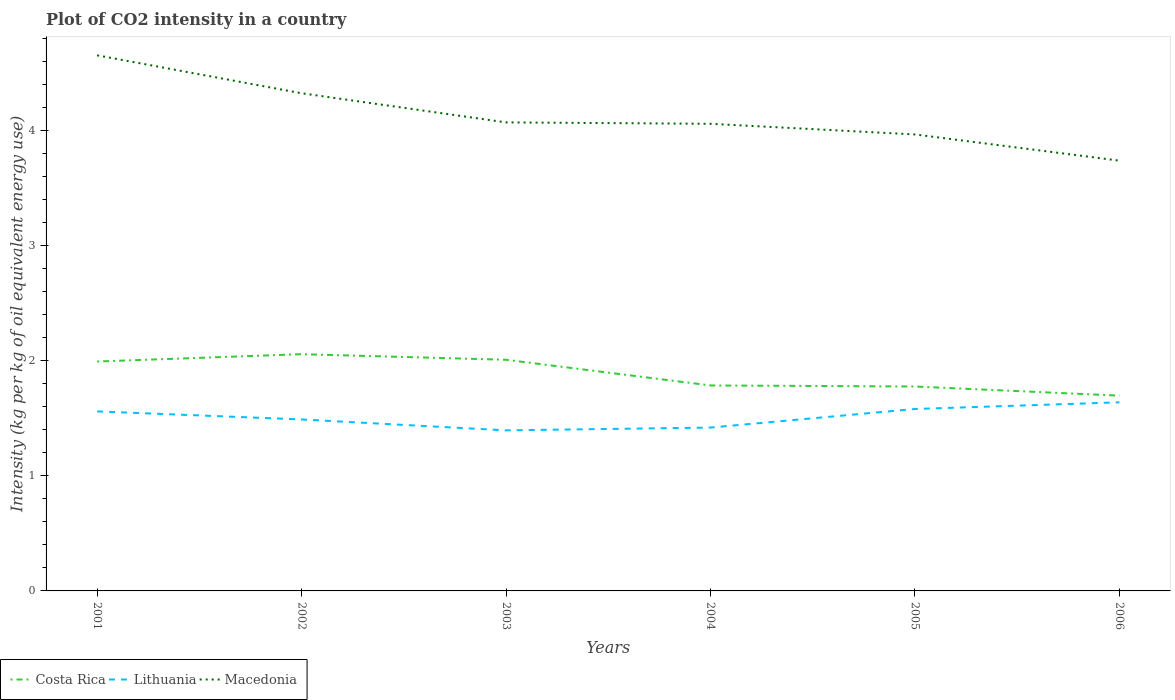Does the line corresponding to Macedonia intersect with the line corresponding to Costa Rica?
Your response must be concise. No. Across all years, what is the maximum CO2 intensity in in Costa Rica?
Provide a succinct answer. 1.7. What is the total CO2 intensity in in Lithuania in the graph?
Keep it short and to the point. -0.09. What is the difference between the highest and the second highest CO2 intensity in in Lithuania?
Give a very brief answer. 0.24. What is the difference between the highest and the lowest CO2 intensity in in Costa Rica?
Ensure brevity in your answer.  3. How many lines are there?
Keep it short and to the point. 3. How many years are there in the graph?
Make the answer very short. 6. What is the difference between two consecutive major ticks on the Y-axis?
Keep it short and to the point. 1. Does the graph contain any zero values?
Your answer should be compact. No. How many legend labels are there?
Ensure brevity in your answer.  3. What is the title of the graph?
Keep it short and to the point. Plot of CO2 intensity in a country. What is the label or title of the Y-axis?
Offer a very short reply. Intensity (kg per kg of oil equivalent energy use). What is the Intensity (kg per kg of oil equivalent energy use) of Costa Rica in 2001?
Keep it short and to the point. 1.99. What is the Intensity (kg per kg of oil equivalent energy use) of Lithuania in 2001?
Ensure brevity in your answer.  1.56. What is the Intensity (kg per kg of oil equivalent energy use) in Macedonia in 2001?
Offer a terse response. 4.66. What is the Intensity (kg per kg of oil equivalent energy use) of Costa Rica in 2002?
Make the answer very short. 2.06. What is the Intensity (kg per kg of oil equivalent energy use) in Lithuania in 2002?
Give a very brief answer. 1.49. What is the Intensity (kg per kg of oil equivalent energy use) of Macedonia in 2002?
Give a very brief answer. 4.33. What is the Intensity (kg per kg of oil equivalent energy use) of Costa Rica in 2003?
Ensure brevity in your answer.  2.01. What is the Intensity (kg per kg of oil equivalent energy use) in Lithuania in 2003?
Offer a terse response. 1.4. What is the Intensity (kg per kg of oil equivalent energy use) in Macedonia in 2003?
Keep it short and to the point. 4.07. What is the Intensity (kg per kg of oil equivalent energy use) in Costa Rica in 2004?
Ensure brevity in your answer.  1.79. What is the Intensity (kg per kg of oil equivalent energy use) in Lithuania in 2004?
Ensure brevity in your answer.  1.42. What is the Intensity (kg per kg of oil equivalent energy use) of Macedonia in 2004?
Your answer should be very brief. 4.06. What is the Intensity (kg per kg of oil equivalent energy use) of Costa Rica in 2005?
Your response must be concise. 1.78. What is the Intensity (kg per kg of oil equivalent energy use) of Lithuania in 2005?
Your answer should be compact. 1.58. What is the Intensity (kg per kg of oil equivalent energy use) of Macedonia in 2005?
Provide a succinct answer. 3.97. What is the Intensity (kg per kg of oil equivalent energy use) of Costa Rica in 2006?
Ensure brevity in your answer.  1.7. What is the Intensity (kg per kg of oil equivalent energy use) of Lithuania in 2006?
Give a very brief answer. 1.64. What is the Intensity (kg per kg of oil equivalent energy use) in Macedonia in 2006?
Your answer should be very brief. 3.74. Across all years, what is the maximum Intensity (kg per kg of oil equivalent energy use) of Costa Rica?
Provide a short and direct response. 2.06. Across all years, what is the maximum Intensity (kg per kg of oil equivalent energy use) of Lithuania?
Make the answer very short. 1.64. Across all years, what is the maximum Intensity (kg per kg of oil equivalent energy use) of Macedonia?
Your response must be concise. 4.66. Across all years, what is the minimum Intensity (kg per kg of oil equivalent energy use) of Costa Rica?
Offer a very short reply. 1.7. Across all years, what is the minimum Intensity (kg per kg of oil equivalent energy use) in Lithuania?
Give a very brief answer. 1.4. Across all years, what is the minimum Intensity (kg per kg of oil equivalent energy use) of Macedonia?
Provide a succinct answer. 3.74. What is the total Intensity (kg per kg of oil equivalent energy use) in Costa Rica in the graph?
Provide a succinct answer. 11.32. What is the total Intensity (kg per kg of oil equivalent energy use) of Lithuania in the graph?
Make the answer very short. 9.09. What is the total Intensity (kg per kg of oil equivalent energy use) of Macedonia in the graph?
Your answer should be compact. 24.83. What is the difference between the Intensity (kg per kg of oil equivalent energy use) in Costa Rica in 2001 and that in 2002?
Your answer should be very brief. -0.06. What is the difference between the Intensity (kg per kg of oil equivalent energy use) of Lithuania in 2001 and that in 2002?
Make the answer very short. 0.07. What is the difference between the Intensity (kg per kg of oil equivalent energy use) of Macedonia in 2001 and that in 2002?
Give a very brief answer. 0.33. What is the difference between the Intensity (kg per kg of oil equivalent energy use) in Costa Rica in 2001 and that in 2003?
Offer a terse response. -0.02. What is the difference between the Intensity (kg per kg of oil equivalent energy use) of Lithuania in 2001 and that in 2003?
Your response must be concise. 0.17. What is the difference between the Intensity (kg per kg of oil equivalent energy use) in Macedonia in 2001 and that in 2003?
Make the answer very short. 0.58. What is the difference between the Intensity (kg per kg of oil equivalent energy use) of Costa Rica in 2001 and that in 2004?
Provide a short and direct response. 0.21. What is the difference between the Intensity (kg per kg of oil equivalent energy use) of Lithuania in 2001 and that in 2004?
Offer a very short reply. 0.14. What is the difference between the Intensity (kg per kg of oil equivalent energy use) of Macedonia in 2001 and that in 2004?
Offer a terse response. 0.6. What is the difference between the Intensity (kg per kg of oil equivalent energy use) of Costa Rica in 2001 and that in 2005?
Keep it short and to the point. 0.22. What is the difference between the Intensity (kg per kg of oil equivalent energy use) in Lithuania in 2001 and that in 2005?
Offer a very short reply. -0.02. What is the difference between the Intensity (kg per kg of oil equivalent energy use) of Macedonia in 2001 and that in 2005?
Keep it short and to the point. 0.69. What is the difference between the Intensity (kg per kg of oil equivalent energy use) of Costa Rica in 2001 and that in 2006?
Provide a short and direct response. 0.3. What is the difference between the Intensity (kg per kg of oil equivalent energy use) in Lithuania in 2001 and that in 2006?
Provide a succinct answer. -0.08. What is the difference between the Intensity (kg per kg of oil equivalent energy use) of Macedonia in 2001 and that in 2006?
Your response must be concise. 0.92. What is the difference between the Intensity (kg per kg of oil equivalent energy use) in Costa Rica in 2002 and that in 2003?
Give a very brief answer. 0.05. What is the difference between the Intensity (kg per kg of oil equivalent energy use) of Lithuania in 2002 and that in 2003?
Give a very brief answer. 0.09. What is the difference between the Intensity (kg per kg of oil equivalent energy use) in Macedonia in 2002 and that in 2003?
Your response must be concise. 0.25. What is the difference between the Intensity (kg per kg of oil equivalent energy use) in Costa Rica in 2002 and that in 2004?
Make the answer very short. 0.27. What is the difference between the Intensity (kg per kg of oil equivalent energy use) in Lithuania in 2002 and that in 2004?
Make the answer very short. 0.07. What is the difference between the Intensity (kg per kg of oil equivalent energy use) of Macedonia in 2002 and that in 2004?
Your response must be concise. 0.27. What is the difference between the Intensity (kg per kg of oil equivalent energy use) in Costa Rica in 2002 and that in 2005?
Give a very brief answer. 0.28. What is the difference between the Intensity (kg per kg of oil equivalent energy use) of Lithuania in 2002 and that in 2005?
Provide a succinct answer. -0.09. What is the difference between the Intensity (kg per kg of oil equivalent energy use) of Macedonia in 2002 and that in 2005?
Provide a short and direct response. 0.36. What is the difference between the Intensity (kg per kg of oil equivalent energy use) of Costa Rica in 2002 and that in 2006?
Your response must be concise. 0.36. What is the difference between the Intensity (kg per kg of oil equivalent energy use) of Lithuania in 2002 and that in 2006?
Offer a terse response. -0.15. What is the difference between the Intensity (kg per kg of oil equivalent energy use) of Macedonia in 2002 and that in 2006?
Offer a terse response. 0.59. What is the difference between the Intensity (kg per kg of oil equivalent energy use) in Costa Rica in 2003 and that in 2004?
Keep it short and to the point. 0.22. What is the difference between the Intensity (kg per kg of oil equivalent energy use) in Lithuania in 2003 and that in 2004?
Provide a succinct answer. -0.02. What is the difference between the Intensity (kg per kg of oil equivalent energy use) of Macedonia in 2003 and that in 2004?
Provide a short and direct response. 0.01. What is the difference between the Intensity (kg per kg of oil equivalent energy use) of Costa Rica in 2003 and that in 2005?
Your answer should be very brief. 0.23. What is the difference between the Intensity (kg per kg of oil equivalent energy use) in Lithuania in 2003 and that in 2005?
Offer a very short reply. -0.19. What is the difference between the Intensity (kg per kg of oil equivalent energy use) in Macedonia in 2003 and that in 2005?
Provide a succinct answer. 0.1. What is the difference between the Intensity (kg per kg of oil equivalent energy use) in Costa Rica in 2003 and that in 2006?
Your answer should be very brief. 0.31. What is the difference between the Intensity (kg per kg of oil equivalent energy use) of Lithuania in 2003 and that in 2006?
Your response must be concise. -0.24. What is the difference between the Intensity (kg per kg of oil equivalent energy use) of Macedonia in 2003 and that in 2006?
Offer a terse response. 0.33. What is the difference between the Intensity (kg per kg of oil equivalent energy use) of Costa Rica in 2004 and that in 2005?
Make the answer very short. 0.01. What is the difference between the Intensity (kg per kg of oil equivalent energy use) in Lithuania in 2004 and that in 2005?
Give a very brief answer. -0.16. What is the difference between the Intensity (kg per kg of oil equivalent energy use) in Macedonia in 2004 and that in 2005?
Ensure brevity in your answer.  0.09. What is the difference between the Intensity (kg per kg of oil equivalent energy use) in Costa Rica in 2004 and that in 2006?
Ensure brevity in your answer.  0.09. What is the difference between the Intensity (kg per kg of oil equivalent energy use) in Lithuania in 2004 and that in 2006?
Offer a terse response. -0.22. What is the difference between the Intensity (kg per kg of oil equivalent energy use) in Macedonia in 2004 and that in 2006?
Keep it short and to the point. 0.32. What is the difference between the Intensity (kg per kg of oil equivalent energy use) in Costa Rica in 2005 and that in 2006?
Give a very brief answer. 0.08. What is the difference between the Intensity (kg per kg of oil equivalent energy use) in Lithuania in 2005 and that in 2006?
Offer a very short reply. -0.06. What is the difference between the Intensity (kg per kg of oil equivalent energy use) in Macedonia in 2005 and that in 2006?
Your response must be concise. 0.23. What is the difference between the Intensity (kg per kg of oil equivalent energy use) in Costa Rica in 2001 and the Intensity (kg per kg of oil equivalent energy use) in Lithuania in 2002?
Your response must be concise. 0.5. What is the difference between the Intensity (kg per kg of oil equivalent energy use) in Costa Rica in 2001 and the Intensity (kg per kg of oil equivalent energy use) in Macedonia in 2002?
Offer a terse response. -2.33. What is the difference between the Intensity (kg per kg of oil equivalent energy use) in Lithuania in 2001 and the Intensity (kg per kg of oil equivalent energy use) in Macedonia in 2002?
Give a very brief answer. -2.77. What is the difference between the Intensity (kg per kg of oil equivalent energy use) of Costa Rica in 2001 and the Intensity (kg per kg of oil equivalent energy use) of Lithuania in 2003?
Offer a very short reply. 0.6. What is the difference between the Intensity (kg per kg of oil equivalent energy use) in Costa Rica in 2001 and the Intensity (kg per kg of oil equivalent energy use) in Macedonia in 2003?
Provide a short and direct response. -2.08. What is the difference between the Intensity (kg per kg of oil equivalent energy use) of Lithuania in 2001 and the Intensity (kg per kg of oil equivalent energy use) of Macedonia in 2003?
Give a very brief answer. -2.51. What is the difference between the Intensity (kg per kg of oil equivalent energy use) of Costa Rica in 2001 and the Intensity (kg per kg of oil equivalent energy use) of Lithuania in 2004?
Your answer should be compact. 0.57. What is the difference between the Intensity (kg per kg of oil equivalent energy use) of Costa Rica in 2001 and the Intensity (kg per kg of oil equivalent energy use) of Macedonia in 2004?
Your answer should be compact. -2.07. What is the difference between the Intensity (kg per kg of oil equivalent energy use) of Lithuania in 2001 and the Intensity (kg per kg of oil equivalent energy use) of Macedonia in 2004?
Offer a very short reply. -2.5. What is the difference between the Intensity (kg per kg of oil equivalent energy use) of Costa Rica in 2001 and the Intensity (kg per kg of oil equivalent energy use) of Lithuania in 2005?
Give a very brief answer. 0.41. What is the difference between the Intensity (kg per kg of oil equivalent energy use) in Costa Rica in 2001 and the Intensity (kg per kg of oil equivalent energy use) in Macedonia in 2005?
Offer a very short reply. -1.97. What is the difference between the Intensity (kg per kg of oil equivalent energy use) of Lithuania in 2001 and the Intensity (kg per kg of oil equivalent energy use) of Macedonia in 2005?
Keep it short and to the point. -2.41. What is the difference between the Intensity (kg per kg of oil equivalent energy use) of Costa Rica in 2001 and the Intensity (kg per kg of oil equivalent energy use) of Lithuania in 2006?
Offer a very short reply. 0.35. What is the difference between the Intensity (kg per kg of oil equivalent energy use) of Costa Rica in 2001 and the Intensity (kg per kg of oil equivalent energy use) of Macedonia in 2006?
Keep it short and to the point. -1.75. What is the difference between the Intensity (kg per kg of oil equivalent energy use) in Lithuania in 2001 and the Intensity (kg per kg of oil equivalent energy use) in Macedonia in 2006?
Your answer should be very brief. -2.18. What is the difference between the Intensity (kg per kg of oil equivalent energy use) of Costa Rica in 2002 and the Intensity (kg per kg of oil equivalent energy use) of Lithuania in 2003?
Offer a terse response. 0.66. What is the difference between the Intensity (kg per kg of oil equivalent energy use) of Costa Rica in 2002 and the Intensity (kg per kg of oil equivalent energy use) of Macedonia in 2003?
Provide a succinct answer. -2.02. What is the difference between the Intensity (kg per kg of oil equivalent energy use) of Lithuania in 2002 and the Intensity (kg per kg of oil equivalent energy use) of Macedonia in 2003?
Ensure brevity in your answer.  -2.58. What is the difference between the Intensity (kg per kg of oil equivalent energy use) of Costa Rica in 2002 and the Intensity (kg per kg of oil equivalent energy use) of Lithuania in 2004?
Provide a short and direct response. 0.64. What is the difference between the Intensity (kg per kg of oil equivalent energy use) in Costa Rica in 2002 and the Intensity (kg per kg of oil equivalent energy use) in Macedonia in 2004?
Your answer should be compact. -2. What is the difference between the Intensity (kg per kg of oil equivalent energy use) of Lithuania in 2002 and the Intensity (kg per kg of oil equivalent energy use) of Macedonia in 2004?
Make the answer very short. -2.57. What is the difference between the Intensity (kg per kg of oil equivalent energy use) in Costa Rica in 2002 and the Intensity (kg per kg of oil equivalent energy use) in Lithuania in 2005?
Provide a succinct answer. 0.48. What is the difference between the Intensity (kg per kg of oil equivalent energy use) of Costa Rica in 2002 and the Intensity (kg per kg of oil equivalent energy use) of Macedonia in 2005?
Your response must be concise. -1.91. What is the difference between the Intensity (kg per kg of oil equivalent energy use) of Lithuania in 2002 and the Intensity (kg per kg of oil equivalent energy use) of Macedonia in 2005?
Give a very brief answer. -2.48. What is the difference between the Intensity (kg per kg of oil equivalent energy use) in Costa Rica in 2002 and the Intensity (kg per kg of oil equivalent energy use) in Lithuania in 2006?
Provide a short and direct response. 0.42. What is the difference between the Intensity (kg per kg of oil equivalent energy use) in Costa Rica in 2002 and the Intensity (kg per kg of oil equivalent energy use) in Macedonia in 2006?
Give a very brief answer. -1.68. What is the difference between the Intensity (kg per kg of oil equivalent energy use) in Lithuania in 2002 and the Intensity (kg per kg of oil equivalent energy use) in Macedonia in 2006?
Make the answer very short. -2.25. What is the difference between the Intensity (kg per kg of oil equivalent energy use) in Costa Rica in 2003 and the Intensity (kg per kg of oil equivalent energy use) in Lithuania in 2004?
Offer a very short reply. 0.59. What is the difference between the Intensity (kg per kg of oil equivalent energy use) in Costa Rica in 2003 and the Intensity (kg per kg of oil equivalent energy use) in Macedonia in 2004?
Your response must be concise. -2.05. What is the difference between the Intensity (kg per kg of oil equivalent energy use) in Lithuania in 2003 and the Intensity (kg per kg of oil equivalent energy use) in Macedonia in 2004?
Give a very brief answer. -2.67. What is the difference between the Intensity (kg per kg of oil equivalent energy use) in Costa Rica in 2003 and the Intensity (kg per kg of oil equivalent energy use) in Lithuania in 2005?
Offer a terse response. 0.43. What is the difference between the Intensity (kg per kg of oil equivalent energy use) of Costa Rica in 2003 and the Intensity (kg per kg of oil equivalent energy use) of Macedonia in 2005?
Your answer should be very brief. -1.96. What is the difference between the Intensity (kg per kg of oil equivalent energy use) in Lithuania in 2003 and the Intensity (kg per kg of oil equivalent energy use) in Macedonia in 2005?
Ensure brevity in your answer.  -2.57. What is the difference between the Intensity (kg per kg of oil equivalent energy use) of Costa Rica in 2003 and the Intensity (kg per kg of oil equivalent energy use) of Lithuania in 2006?
Offer a very short reply. 0.37. What is the difference between the Intensity (kg per kg of oil equivalent energy use) in Costa Rica in 2003 and the Intensity (kg per kg of oil equivalent energy use) in Macedonia in 2006?
Your answer should be very brief. -1.73. What is the difference between the Intensity (kg per kg of oil equivalent energy use) of Lithuania in 2003 and the Intensity (kg per kg of oil equivalent energy use) of Macedonia in 2006?
Keep it short and to the point. -2.34. What is the difference between the Intensity (kg per kg of oil equivalent energy use) of Costa Rica in 2004 and the Intensity (kg per kg of oil equivalent energy use) of Lithuania in 2005?
Make the answer very short. 0.2. What is the difference between the Intensity (kg per kg of oil equivalent energy use) in Costa Rica in 2004 and the Intensity (kg per kg of oil equivalent energy use) in Macedonia in 2005?
Your answer should be compact. -2.18. What is the difference between the Intensity (kg per kg of oil equivalent energy use) of Lithuania in 2004 and the Intensity (kg per kg of oil equivalent energy use) of Macedonia in 2005?
Offer a terse response. -2.55. What is the difference between the Intensity (kg per kg of oil equivalent energy use) of Costa Rica in 2004 and the Intensity (kg per kg of oil equivalent energy use) of Lithuania in 2006?
Provide a succinct answer. 0.15. What is the difference between the Intensity (kg per kg of oil equivalent energy use) in Costa Rica in 2004 and the Intensity (kg per kg of oil equivalent energy use) in Macedonia in 2006?
Your answer should be very brief. -1.95. What is the difference between the Intensity (kg per kg of oil equivalent energy use) of Lithuania in 2004 and the Intensity (kg per kg of oil equivalent energy use) of Macedonia in 2006?
Provide a short and direct response. -2.32. What is the difference between the Intensity (kg per kg of oil equivalent energy use) in Costa Rica in 2005 and the Intensity (kg per kg of oil equivalent energy use) in Lithuania in 2006?
Your answer should be compact. 0.14. What is the difference between the Intensity (kg per kg of oil equivalent energy use) in Costa Rica in 2005 and the Intensity (kg per kg of oil equivalent energy use) in Macedonia in 2006?
Your response must be concise. -1.96. What is the difference between the Intensity (kg per kg of oil equivalent energy use) of Lithuania in 2005 and the Intensity (kg per kg of oil equivalent energy use) of Macedonia in 2006?
Your answer should be compact. -2.16. What is the average Intensity (kg per kg of oil equivalent energy use) in Costa Rica per year?
Your answer should be compact. 1.89. What is the average Intensity (kg per kg of oil equivalent energy use) in Lithuania per year?
Your response must be concise. 1.51. What is the average Intensity (kg per kg of oil equivalent energy use) in Macedonia per year?
Provide a short and direct response. 4.14. In the year 2001, what is the difference between the Intensity (kg per kg of oil equivalent energy use) of Costa Rica and Intensity (kg per kg of oil equivalent energy use) of Lithuania?
Ensure brevity in your answer.  0.43. In the year 2001, what is the difference between the Intensity (kg per kg of oil equivalent energy use) of Costa Rica and Intensity (kg per kg of oil equivalent energy use) of Macedonia?
Your response must be concise. -2.66. In the year 2001, what is the difference between the Intensity (kg per kg of oil equivalent energy use) in Lithuania and Intensity (kg per kg of oil equivalent energy use) in Macedonia?
Offer a very short reply. -3.1. In the year 2002, what is the difference between the Intensity (kg per kg of oil equivalent energy use) of Costa Rica and Intensity (kg per kg of oil equivalent energy use) of Lithuania?
Offer a very short reply. 0.57. In the year 2002, what is the difference between the Intensity (kg per kg of oil equivalent energy use) in Costa Rica and Intensity (kg per kg of oil equivalent energy use) in Macedonia?
Provide a short and direct response. -2.27. In the year 2002, what is the difference between the Intensity (kg per kg of oil equivalent energy use) in Lithuania and Intensity (kg per kg of oil equivalent energy use) in Macedonia?
Provide a short and direct response. -2.84. In the year 2003, what is the difference between the Intensity (kg per kg of oil equivalent energy use) of Costa Rica and Intensity (kg per kg of oil equivalent energy use) of Lithuania?
Your answer should be very brief. 0.61. In the year 2003, what is the difference between the Intensity (kg per kg of oil equivalent energy use) of Costa Rica and Intensity (kg per kg of oil equivalent energy use) of Macedonia?
Offer a very short reply. -2.06. In the year 2003, what is the difference between the Intensity (kg per kg of oil equivalent energy use) in Lithuania and Intensity (kg per kg of oil equivalent energy use) in Macedonia?
Offer a very short reply. -2.68. In the year 2004, what is the difference between the Intensity (kg per kg of oil equivalent energy use) of Costa Rica and Intensity (kg per kg of oil equivalent energy use) of Lithuania?
Give a very brief answer. 0.37. In the year 2004, what is the difference between the Intensity (kg per kg of oil equivalent energy use) of Costa Rica and Intensity (kg per kg of oil equivalent energy use) of Macedonia?
Ensure brevity in your answer.  -2.27. In the year 2004, what is the difference between the Intensity (kg per kg of oil equivalent energy use) of Lithuania and Intensity (kg per kg of oil equivalent energy use) of Macedonia?
Make the answer very short. -2.64. In the year 2005, what is the difference between the Intensity (kg per kg of oil equivalent energy use) in Costa Rica and Intensity (kg per kg of oil equivalent energy use) in Lithuania?
Make the answer very short. 0.2. In the year 2005, what is the difference between the Intensity (kg per kg of oil equivalent energy use) of Costa Rica and Intensity (kg per kg of oil equivalent energy use) of Macedonia?
Keep it short and to the point. -2.19. In the year 2005, what is the difference between the Intensity (kg per kg of oil equivalent energy use) in Lithuania and Intensity (kg per kg of oil equivalent energy use) in Macedonia?
Give a very brief answer. -2.39. In the year 2006, what is the difference between the Intensity (kg per kg of oil equivalent energy use) in Costa Rica and Intensity (kg per kg of oil equivalent energy use) in Lithuania?
Ensure brevity in your answer.  0.06. In the year 2006, what is the difference between the Intensity (kg per kg of oil equivalent energy use) of Costa Rica and Intensity (kg per kg of oil equivalent energy use) of Macedonia?
Make the answer very short. -2.04. In the year 2006, what is the difference between the Intensity (kg per kg of oil equivalent energy use) of Lithuania and Intensity (kg per kg of oil equivalent energy use) of Macedonia?
Provide a short and direct response. -2.1. What is the ratio of the Intensity (kg per kg of oil equivalent energy use) in Lithuania in 2001 to that in 2002?
Offer a very short reply. 1.05. What is the ratio of the Intensity (kg per kg of oil equivalent energy use) in Macedonia in 2001 to that in 2002?
Your response must be concise. 1.08. What is the ratio of the Intensity (kg per kg of oil equivalent energy use) in Lithuania in 2001 to that in 2003?
Make the answer very short. 1.12. What is the ratio of the Intensity (kg per kg of oil equivalent energy use) in Macedonia in 2001 to that in 2003?
Offer a terse response. 1.14. What is the ratio of the Intensity (kg per kg of oil equivalent energy use) of Costa Rica in 2001 to that in 2004?
Ensure brevity in your answer.  1.12. What is the ratio of the Intensity (kg per kg of oil equivalent energy use) of Lithuania in 2001 to that in 2004?
Ensure brevity in your answer.  1.1. What is the ratio of the Intensity (kg per kg of oil equivalent energy use) of Macedonia in 2001 to that in 2004?
Your response must be concise. 1.15. What is the ratio of the Intensity (kg per kg of oil equivalent energy use) of Costa Rica in 2001 to that in 2005?
Offer a terse response. 1.12. What is the ratio of the Intensity (kg per kg of oil equivalent energy use) of Lithuania in 2001 to that in 2005?
Your answer should be very brief. 0.99. What is the ratio of the Intensity (kg per kg of oil equivalent energy use) of Macedonia in 2001 to that in 2005?
Make the answer very short. 1.17. What is the ratio of the Intensity (kg per kg of oil equivalent energy use) of Costa Rica in 2001 to that in 2006?
Offer a very short reply. 1.17. What is the ratio of the Intensity (kg per kg of oil equivalent energy use) in Lithuania in 2001 to that in 2006?
Make the answer very short. 0.95. What is the ratio of the Intensity (kg per kg of oil equivalent energy use) of Macedonia in 2001 to that in 2006?
Your answer should be compact. 1.24. What is the ratio of the Intensity (kg per kg of oil equivalent energy use) in Costa Rica in 2002 to that in 2003?
Give a very brief answer. 1.02. What is the ratio of the Intensity (kg per kg of oil equivalent energy use) in Lithuania in 2002 to that in 2003?
Your response must be concise. 1.07. What is the ratio of the Intensity (kg per kg of oil equivalent energy use) in Macedonia in 2002 to that in 2003?
Provide a succinct answer. 1.06. What is the ratio of the Intensity (kg per kg of oil equivalent energy use) in Costa Rica in 2002 to that in 2004?
Your answer should be very brief. 1.15. What is the ratio of the Intensity (kg per kg of oil equivalent energy use) in Lithuania in 2002 to that in 2004?
Give a very brief answer. 1.05. What is the ratio of the Intensity (kg per kg of oil equivalent energy use) in Macedonia in 2002 to that in 2004?
Offer a terse response. 1.07. What is the ratio of the Intensity (kg per kg of oil equivalent energy use) in Costa Rica in 2002 to that in 2005?
Your answer should be very brief. 1.16. What is the ratio of the Intensity (kg per kg of oil equivalent energy use) in Lithuania in 2002 to that in 2005?
Your answer should be very brief. 0.94. What is the ratio of the Intensity (kg per kg of oil equivalent energy use) in Macedonia in 2002 to that in 2005?
Provide a succinct answer. 1.09. What is the ratio of the Intensity (kg per kg of oil equivalent energy use) in Costa Rica in 2002 to that in 2006?
Your response must be concise. 1.21. What is the ratio of the Intensity (kg per kg of oil equivalent energy use) in Macedonia in 2002 to that in 2006?
Your answer should be compact. 1.16. What is the ratio of the Intensity (kg per kg of oil equivalent energy use) in Lithuania in 2003 to that in 2004?
Offer a terse response. 0.98. What is the ratio of the Intensity (kg per kg of oil equivalent energy use) of Macedonia in 2003 to that in 2004?
Provide a short and direct response. 1. What is the ratio of the Intensity (kg per kg of oil equivalent energy use) in Costa Rica in 2003 to that in 2005?
Your response must be concise. 1.13. What is the ratio of the Intensity (kg per kg of oil equivalent energy use) in Lithuania in 2003 to that in 2005?
Offer a terse response. 0.88. What is the ratio of the Intensity (kg per kg of oil equivalent energy use) in Macedonia in 2003 to that in 2005?
Provide a short and direct response. 1.03. What is the ratio of the Intensity (kg per kg of oil equivalent energy use) in Costa Rica in 2003 to that in 2006?
Your answer should be very brief. 1.18. What is the ratio of the Intensity (kg per kg of oil equivalent energy use) in Lithuania in 2003 to that in 2006?
Give a very brief answer. 0.85. What is the ratio of the Intensity (kg per kg of oil equivalent energy use) in Macedonia in 2003 to that in 2006?
Your response must be concise. 1.09. What is the ratio of the Intensity (kg per kg of oil equivalent energy use) of Costa Rica in 2004 to that in 2005?
Provide a short and direct response. 1.01. What is the ratio of the Intensity (kg per kg of oil equivalent energy use) in Lithuania in 2004 to that in 2005?
Offer a very short reply. 0.9. What is the ratio of the Intensity (kg per kg of oil equivalent energy use) in Macedonia in 2004 to that in 2005?
Offer a terse response. 1.02. What is the ratio of the Intensity (kg per kg of oil equivalent energy use) in Costa Rica in 2004 to that in 2006?
Offer a terse response. 1.05. What is the ratio of the Intensity (kg per kg of oil equivalent energy use) in Lithuania in 2004 to that in 2006?
Make the answer very short. 0.87. What is the ratio of the Intensity (kg per kg of oil equivalent energy use) in Macedonia in 2004 to that in 2006?
Your answer should be compact. 1.09. What is the ratio of the Intensity (kg per kg of oil equivalent energy use) in Costa Rica in 2005 to that in 2006?
Ensure brevity in your answer.  1.05. What is the ratio of the Intensity (kg per kg of oil equivalent energy use) in Lithuania in 2005 to that in 2006?
Keep it short and to the point. 0.96. What is the ratio of the Intensity (kg per kg of oil equivalent energy use) of Macedonia in 2005 to that in 2006?
Make the answer very short. 1.06. What is the difference between the highest and the second highest Intensity (kg per kg of oil equivalent energy use) in Costa Rica?
Your answer should be compact. 0.05. What is the difference between the highest and the second highest Intensity (kg per kg of oil equivalent energy use) of Lithuania?
Your response must be concise. 0.06. What is the difference between the highest and the second highest Intensity (kg per kg of oil equivalent energy use) in Macedonia?
Offer a very short reply. 0.33. What is the difference between the highest and the lowest Intensity (kg per kg of oil equivalent energy use) of Costa Rica?
Ensure brevity in your answer.  0.36. What is the difference between the highest and the lowest Intensity (kg per kg of oil equivalent energy use) of Lithuania?
Your answer should be very brief. 0.24. What is the difference between the highest and the lowest Intensity (kg per kg of oil equivalent energy use) of Macedonia?
Your answer should be compact. 0.92. 